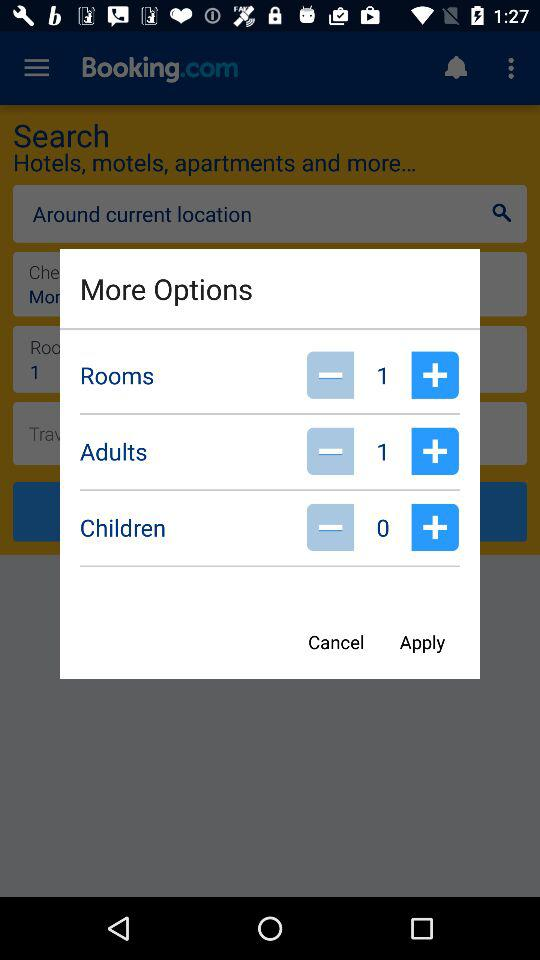What is the number of children added to the option? The number of children is 0 added to the option. 